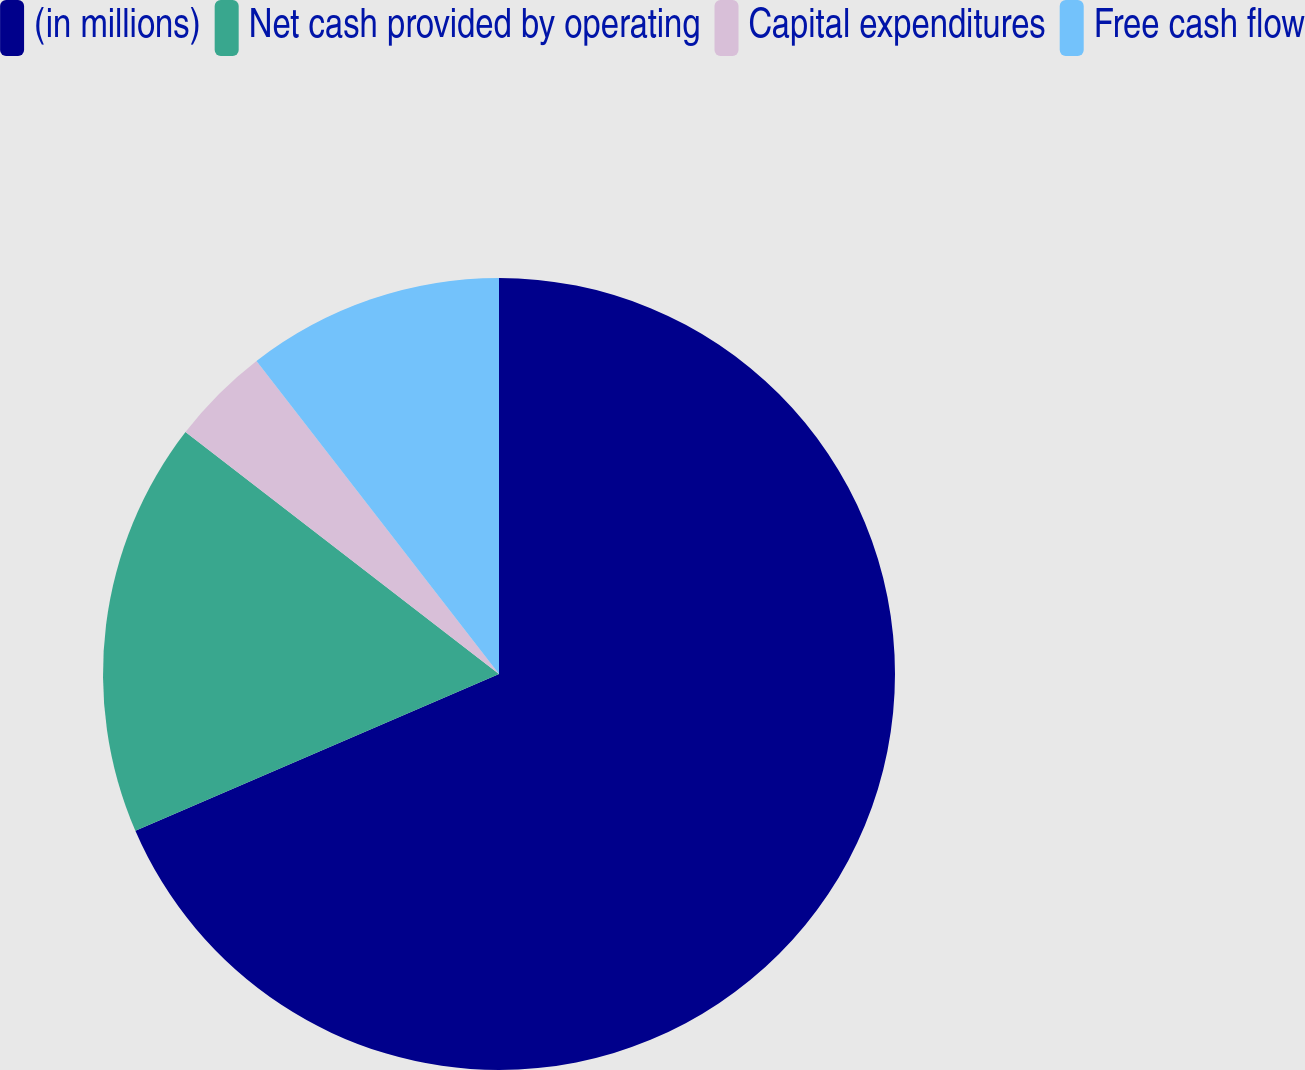Convert chart to OTSL. <chart><loc_0><loc_0><loc_500><loc_500><pie_chart><fcel>(in millions)<fcel>Net cash provided by operating<fcel>Capital expenditures<fcel>Free cash flow<nl><fcel>68.52%<fcel>16.94%<fcel>4.05%<fcel>10.49%<nl></chart> 